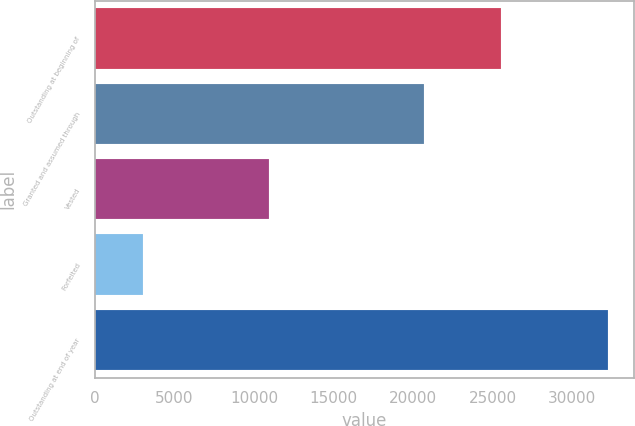Convert chart to OTSL. <chart><loc_0><loc_0><loc_500><loc_500><bar_chart><fcel>Outstanding at beginning of<fcel>Granted and assumed through<fcel>Vested<fcel>Forfeited<fcel>Outstanding at end of year<nl><fcel>25532<fcel>20707<fcel>10966<fcel>3011<fcel>32262<nl></chart> 